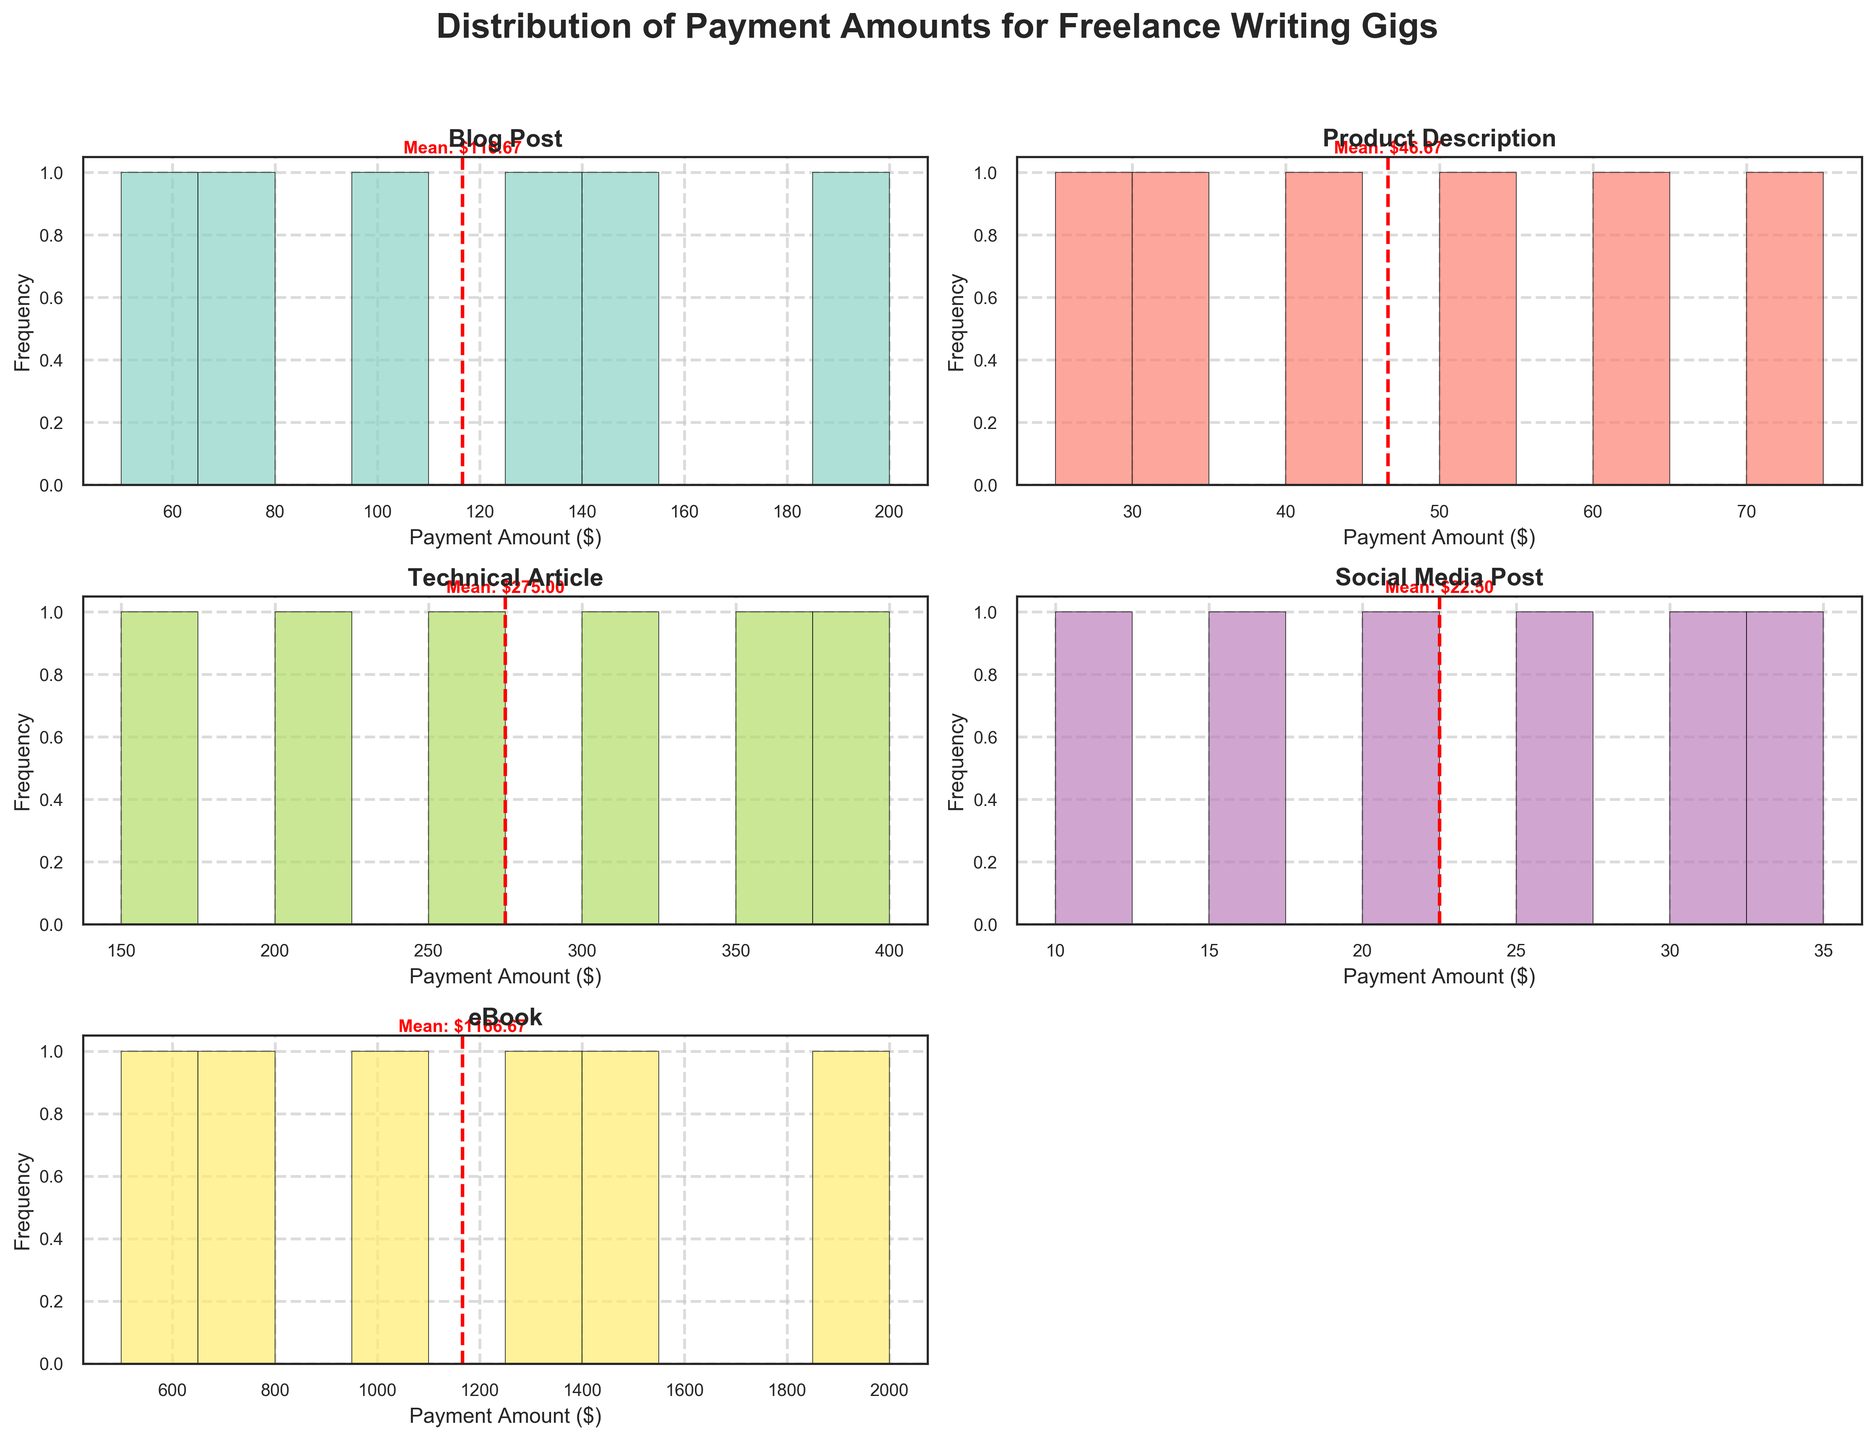What is the title of the figure? The title is the text at the top of the figure. It describes what the figure is about.
Answer: "Distribution of Payment Amounts for Freelance Writing Gigs" Which content type has the highest individual payment amount? By looking at the x-axis for each subplot, you can identify the highest value. The 'eBook' subplot shows values up to $2000.
Answer: eBook How many bins are used in the histograms? Count the number of bars in one of the histograms. Each histogram has 10 bars.
Answer: 10 Which content type has the lowest average payment amount? For each subplot, look at the red dashed line indicating the mean. 'Social Media Post' has the lowest mean value, which is around $20.
Answer: Social Media Post What is the mean payment amount for Technical Articles? Look at the red dashed line in the subplot for Technical Articles. The line points to the value around $275.
Answer: $275 Are there more payment values above $100 or below $100 for Blog Posts? Observe the histogram of payments for Blog Posts. Most of the values appear to fall above $100.
Answer: Above $100 Which two content types have the most similar average payment amounts? Compare the positions of the red dashed lines across the subplots. Blog Post and Product Description have quite close mean payment values.
Answer: Blog Post and Product Description Which content type shows the widest range of payment amounts? Look at the spread of bars in each histogram. eBook has the widest range, going from $500 to $2000.
Answer: eBook What is the frequency of the highest bin for Product Descriptions? Count the height of the highest bin in the Product Description histogram. The highest bin frequency is for the $30-$40 range with a frequency around 2.
Answer: 2 For which content type is the mean payment approximately $75? Look for the red dashed lines pointing to $75. Both Blog Post and Product Description have a mean payment around $75.
Answer: Blog Post and Product Description 